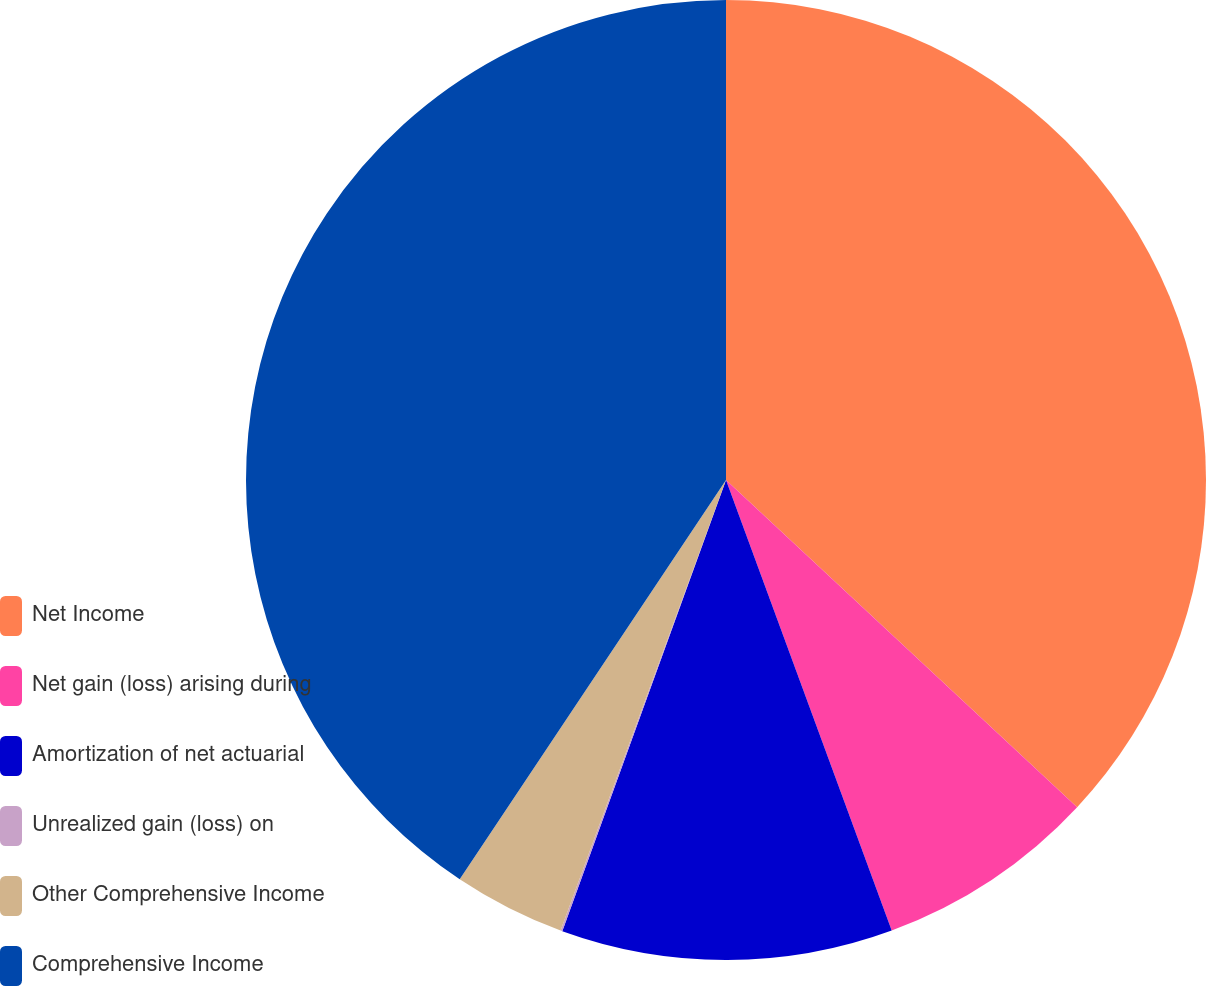<chart> <loc_0><loc_0><loc_500><loc_500><pie_chart><fcel>Net Income<fcel>Net gain (loss) arising during<fcel>Amortization of net actuarial<fcel>Unrealized gain (loss) on<fcel>Other Comprehensive Income<fcel>Comprehensive Income<nl><fcel>36.94%<fcel>7.45%<fcel>11.15%<fcel>0.06%<fcel>3.76%<fcel>40.64%<nl></chart> 